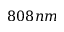Convert formula to latex. <formula><loc_0><loc_0><loc_500><loc_500>8 0 8 n m</formula> 